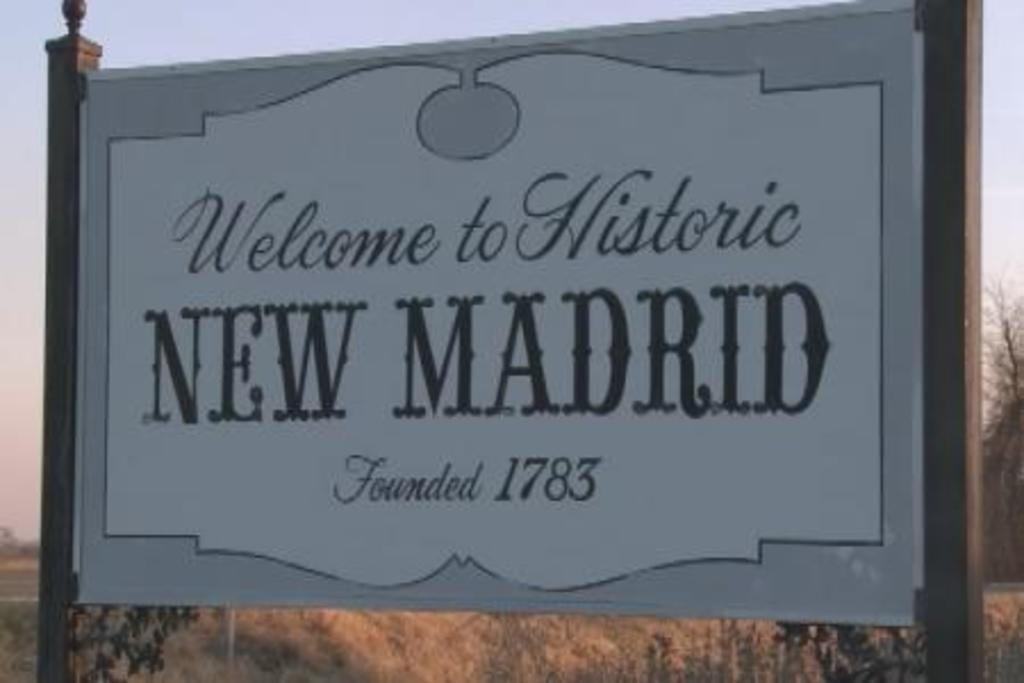<image>
Provide a brief description of the given image. A sign that reads Welcome to Historic NEW MADRID. 